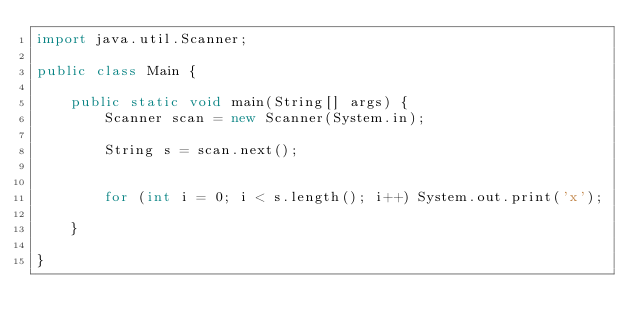Convert code to text. <code><loc_0><loc_0><loc_500><loc_500><_Java_>import java.util.Scanner;

public class Main {

	public static void main(String[] args) {
		Scanner scan = new Scanner(System.in);
		
		String s = scan.next();
		
		
		for (int i = 0; i < s.length(); i++) System.out.print('x');

	}

}</code> 